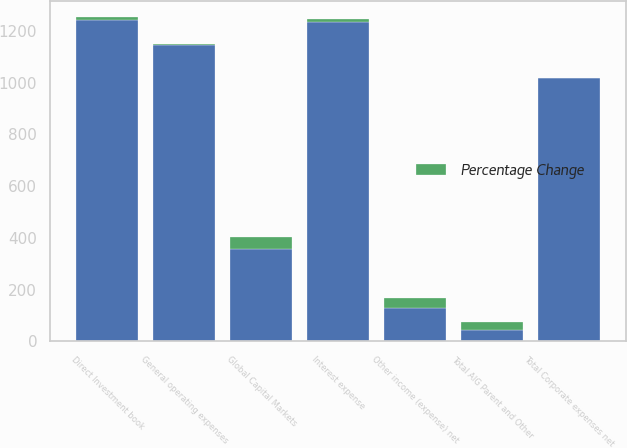Convert chart to OTSL. <chart><loc_0><loc_0><loc_500><loc_500><stacked_bar_chart><ecel><fcel>Direct Investment book<fcel>Global Capital Markets<fcel>Other income (expense) net<fcel>General operating expenses<fcel>Total Corporate expenses net<fcel>Interest expense<fcel>Total AIG Parent and Other<nl><fcel>nan<fcel>1241<fcel>359<fcel>128<fcel>1146<fcel>1018<fcel>1233<fcel>43<nl><fcel>Percentage Change<fcel>14<fcel>43<fcel>42<fcel>3<fcel>1<fcel>13<fcel>34<nl></chart> 